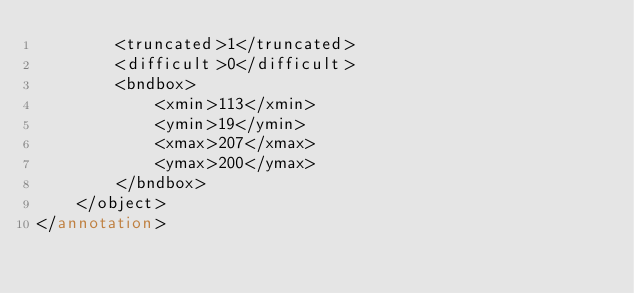<code> <loc_0><loc_0><loc_500><loc_500><_XML_>		<truncated>1</truncated>
		<difficult>0</difficult>
		<bndbox>
			<xmin>113</xmin>
			<ymin>19</ymin>
			<xmax>207</xmax>
			<ymax>200</ymax>
		</bndbox>
	</object>
</annotation>
</code> 